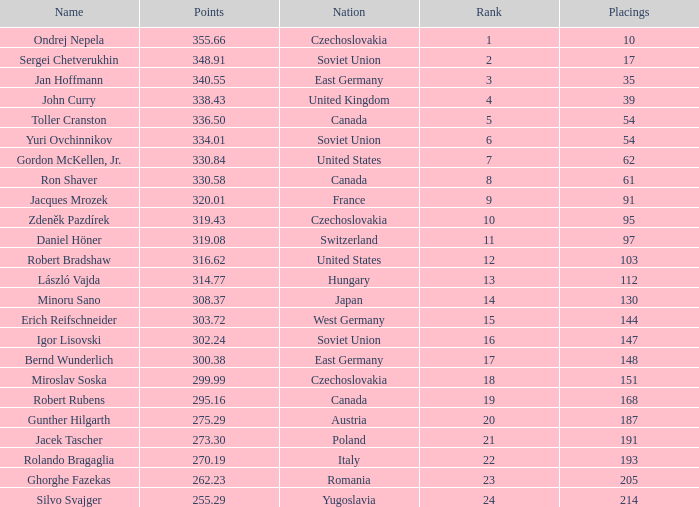Which Placings have a Nation of west germany, and Points larger than 303.72? None. 